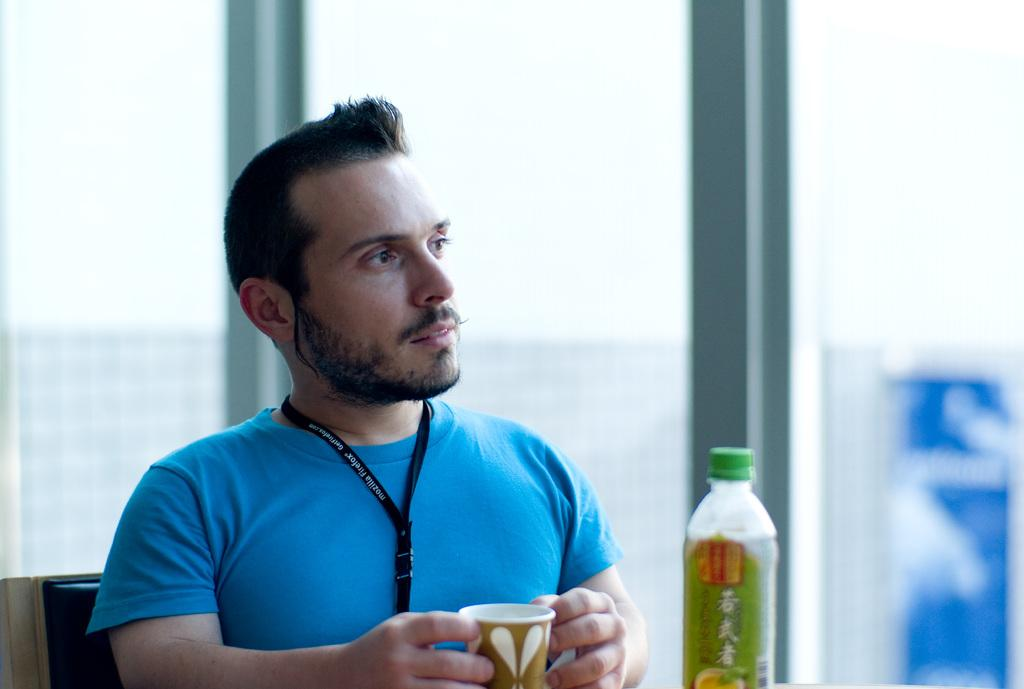What is the main subject of the image? There is a person in the image. What is the person wearing? The person is wearing a blue t-shirt. What is the person sitting on? The person is sitting on a black chair. What is the person holding? The person is holding a cup. What can be seen at the front of the image? There is a bottle at the front of the image. What color is the label on the bottle? The label on the bottle is green. Can you see a hen sitting on a nest in the image? No, there is no hen or nest present in the image. 